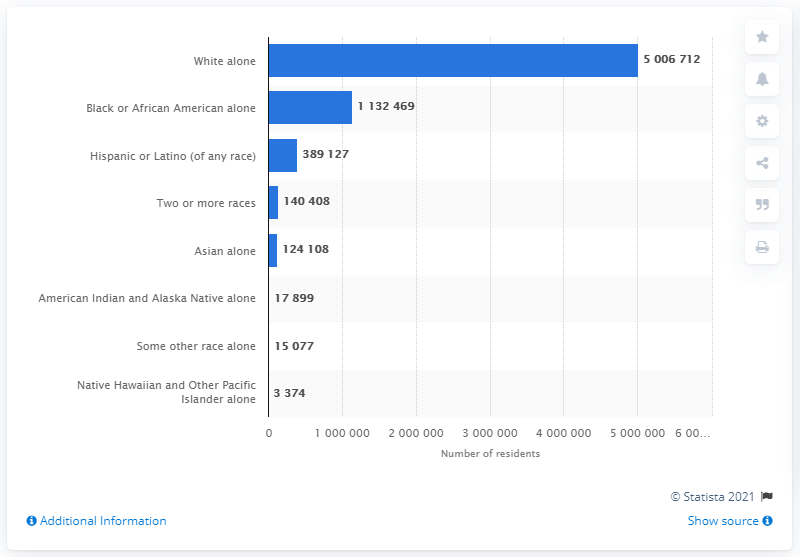Give some essential details in this illustration. In 2019, the number of Black or African American residents in the state of Tennessee was approximately 1,132,469. 